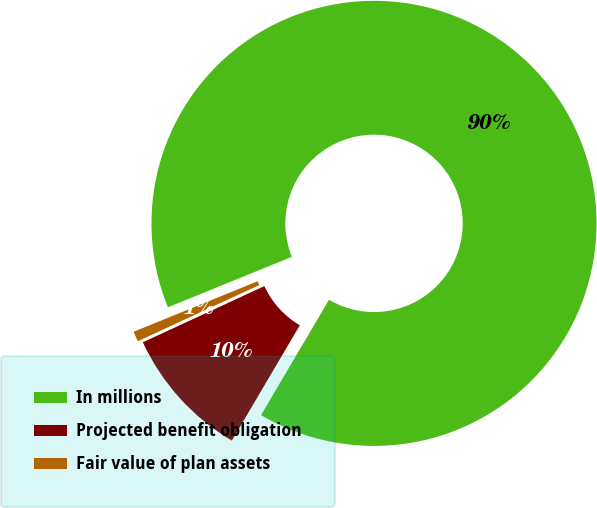Convert chart to OTSL. <chart><loc_0><loc_0><loc_500><loc_500><pie_chart><fcel>In millions<fcel>Projected benefit obligation<fcel>Fair value of plan assets<nl><fcel>89.63%<fcel>9.63%<fcel>0.74%<nl></chart> 